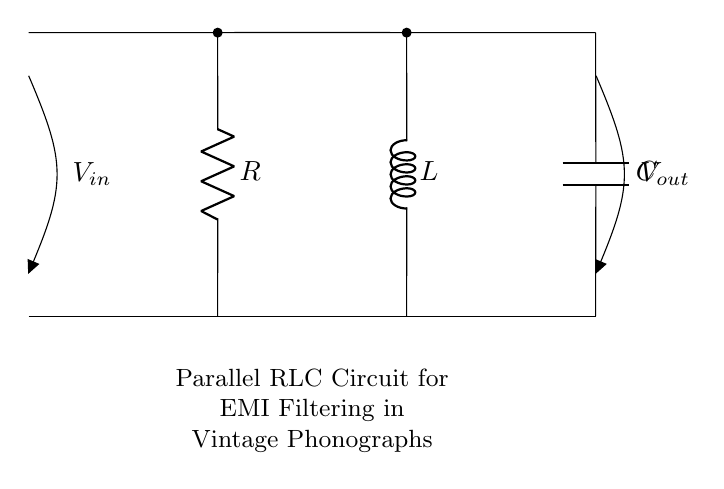What components are present in this circuit? The circuit diagram features three components: a resistor, an inductor, and a capacitor, which are arranged in parallel. The labels R, L, and C directly correspond to these components.
Answer: Resistor, Inductor, Capacitor What is the purpose of this circuit? The schematic indicates that this parallel RLC circuit is designed for electromagnetic interference filtering, particularly for vintage phonographs, as noted in the description beneath the circuit.
Answer: EMI Filtering How are the components connected? In the circuit, the resistor, inductor, and capacitor are all connected in parallel between the input and output voltage points, allowing them to work simultaneously to filter interference.
Answer: Parallel What is the voltage across each component? In a parallel circuit, the voltage across each component is the same and equal to the input voltage, denoted as V_in in the arrangement.
Answer: V_in Which component will provide the most resistance to high frequencies? In an RLC circuit, the inductor provides high resistance to high frequencies due to its property of opposing changes in current through inductance, while allowing lower frequencies to pass.
Answer: Inductor How does changing the value of the capacitor affect the circuit? Altering the capacitance value will affect the cutoff frequency of the filter. An increase in capacitance will lower the cutoff frequency, allowing more low frequencies to pass while attenuating high frequencies, and vice versa.
Answer: Cutoff frequency What type of noise does this circuit aim to filter out? This parallel RLC circuit aims to filter out electromagnetic interference noise, which may originate from various sources and disrupt the performance of vintage phonographs.
Answer: Electromagnetic interference 